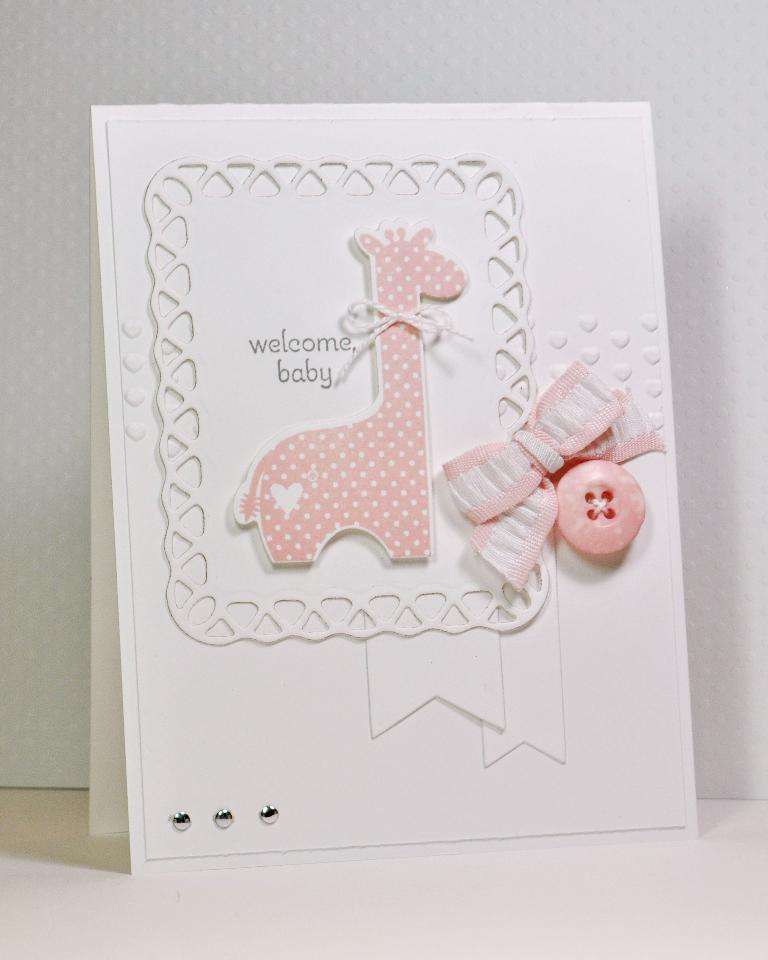What is the main object in the image? There is a card in the image. What decorations are on the card? The card has a bow and a button on it. What can be read on the card? There are words on the card. What type of animal is depicted on the card? There is a sticker of a giraffe on the card. What is visible behind the card? There is a wall behind the card. How does the turkey feel about the pain it experienced in the image? There is no turkey or mention of pain in the image; it features a card with various decorations and a giraffe sticker. 